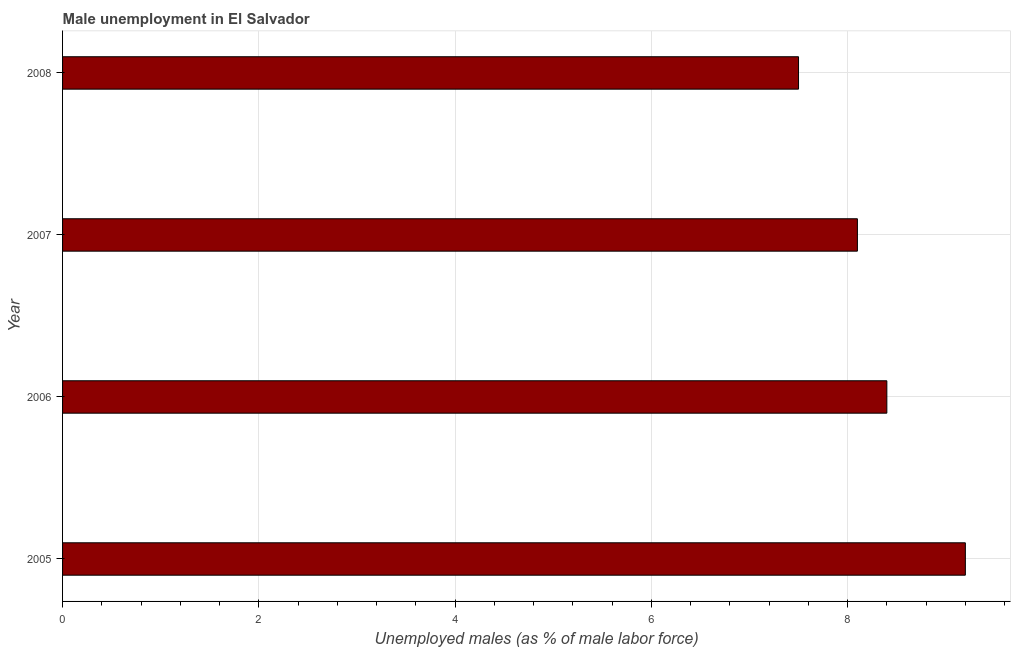Does the graph contain any zero values?
Ensure brevity in your answer.  No. What is the title of the graph?
Ensure brevity in your answer.  Male unemployment in El Salvador. What is the label or title of the X-axis?
Ensure brevity in your answer.  Unemployed males (as % of male labor force). What is the unemployed males population in 2007?
Ensure brevity in your answer.  8.1. Across all years, what is the maximum unemployed males population?
Provide a short and direct response. 9.2. Across all years, what is the minimum unemployed males population?
Give a very brief answer. 7.5. In which year was the unemployed males population minimum?
Your answer should be very brief. 2008. What is the sum of the unemployed males population?
Your answer should be compact. 33.2. What is the difference between the unemployed males population in 2006 and 2007?
Keep it short and to the point. 0.3. What is the average unemployed males population per year?
Give a very brief answer. 8.3. What is the median unemployed males population?
Provide a succinct answer. 8.25. In how many years, is the unemployed males population greater than 4 %?
Give a very brief answer. 4. Do a majority of the years between 2006 and 2005 (inclusive) have unemployed males population greater than 6.4 %?
Provide a succinct answer. No. What is the ratio of the unemployed males population in 2006 to that in 2007?
Give a very brief answer. 1.04. Is the unemployed males population in 2005 less than that in 2007?
Provide a short and direct response. No. Is the difference between the unemployed males population in 2005 and 2007 greater than the difference between any two years?
Keep it short and to the point. No. What is the difference between the highest and the second highest unemployed males population?
Offer a very short reply. 0.8. In how many years, is the unemployed males population greater than the average unemployed males population taken over all years?
Make the answer very short. 2. Are all the bars in the graph horizontal?
Ensure brevity in your answer.  Yes. What is the Unemployed males (as % of male labor force) of 2005?
Keep it short and to the point. 9.2. What is the Unemployed males (as % of male labor force) of 2006?
Offer a very short reply. 8.4. What is the Unemployed males (as % of male labor force) in 2007?
Ensure brevity in your answer.  8.1. What is the difference between the Unemployed males (as % of male labor force) in 2005 and 2006?
Keep it short and to the point. 0.8. What is the difference between the Unemployed males (as % of male labor force) in 2005 and 2008?
Your answer should be very brief. 1.7. What is the difference between the Unemployed males (as % of male labor force) in 2006 and 2008?
Offer a terse response. 0.9. What is the ratio of the Unemployed males (as % of male labor force) in 2005 to that in 2006?
Your answer should be very brief. 1.09. What is the ratio of the Unemployed males (as % of male labor force) in 2005 to that in 2007?
Your answer should be compact. 1.14. What is the ratio of the Unemployed males (as % of male labor force) in 2005 to that in 2008?
Offer a terse response. 1.23. What is the ratio of the Unemployed males (as % of male labor force) in 2006 to that in 2008?
Offer a very short reply. 1.12. 